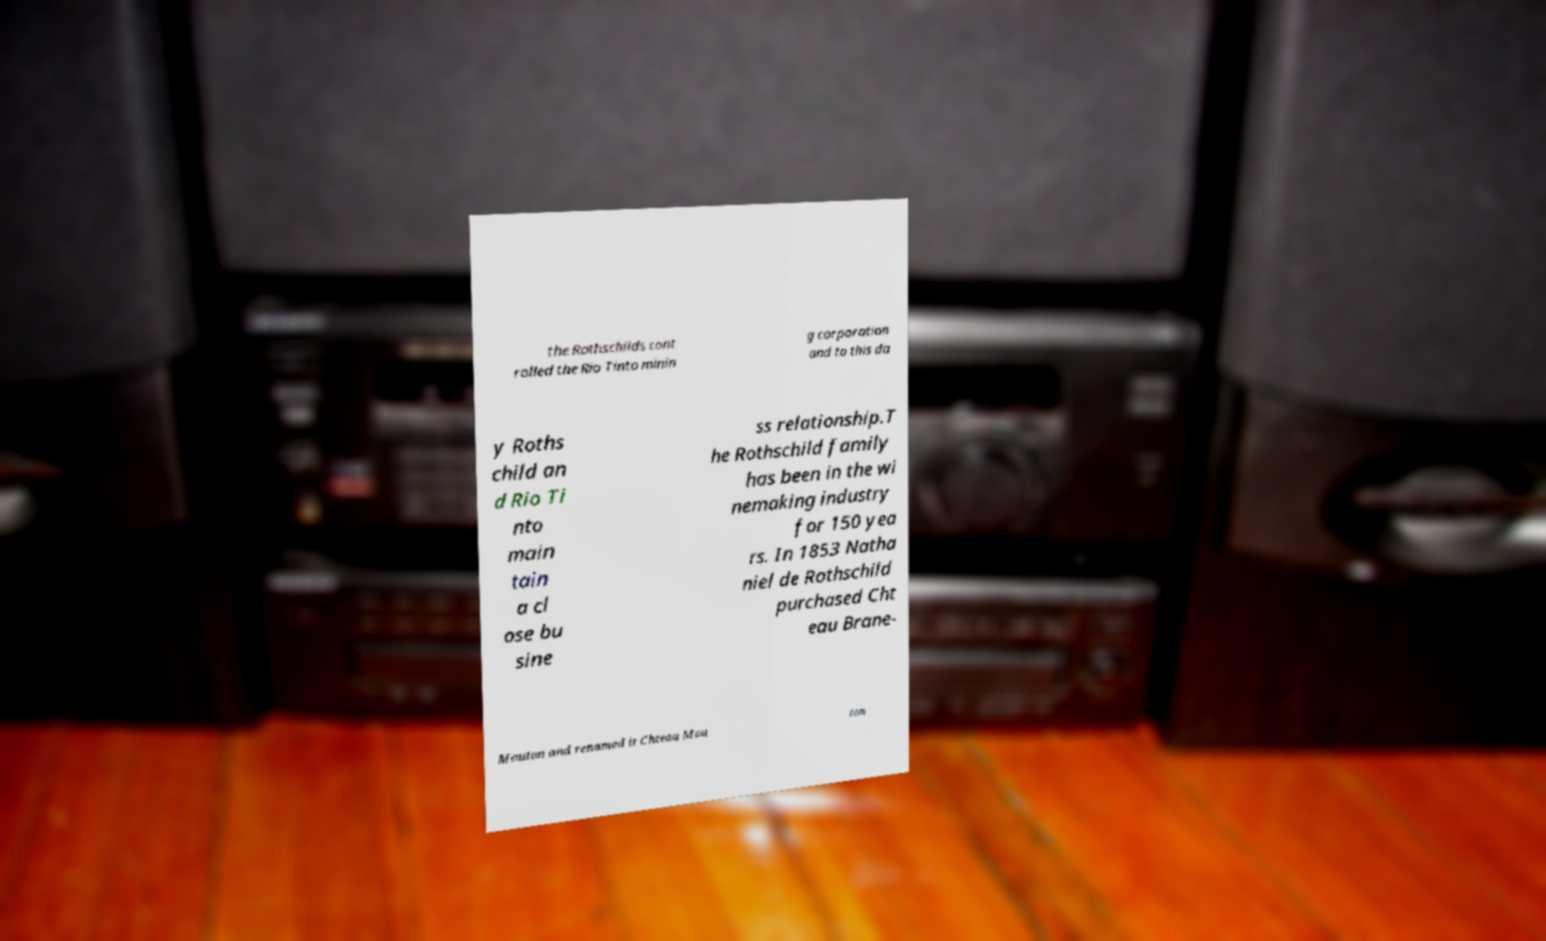Can you read and provide the text displayed in the image?This photo seems to have some interesting text. Can you extract and type it out for me? the Rothschilds cont rolled the Rio Tinto minin g corporation and to this da y Roths child an d Rio Ti nto main tain a cl ose bu sine ss relationship.T he Rothschild family has been in the wi nemaking industry for 150 yea rs. In 1853 Natha niel de Rothschild purchased Cht eau Brane- Mouton and renamed it Chteau Mou ton 